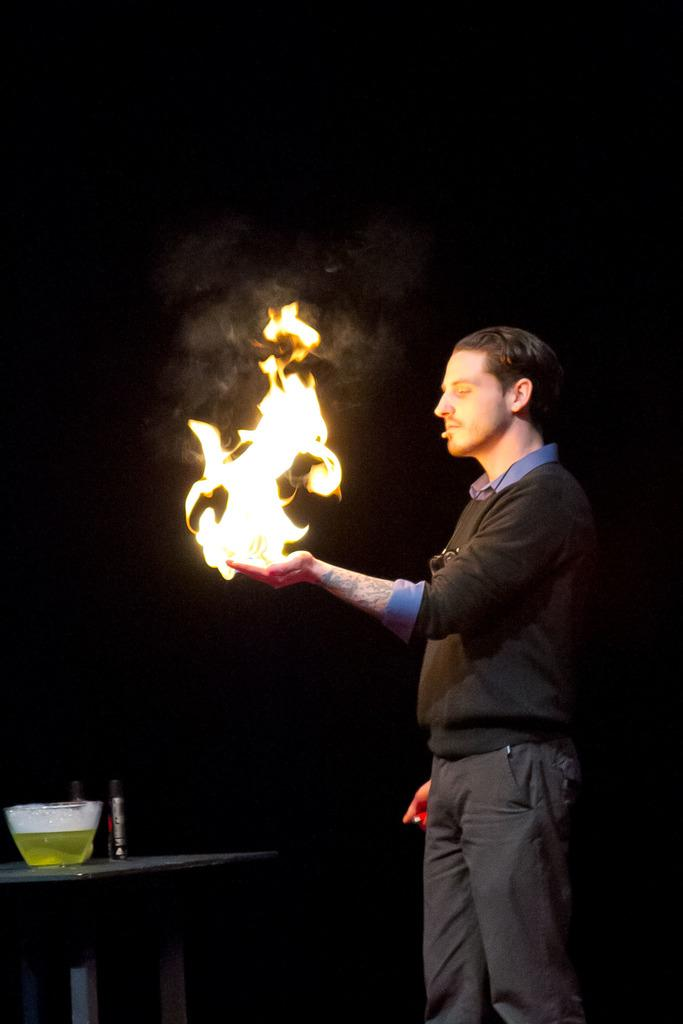What is located on the right side of the image? There is a man on the right side of the image. What is the man wearing? The man is wearing a t-shirt and trousers. What is the man holding in the image? The man is holding fire. What can be seen on the left side of the image? There is a table on the left side of the image. What items are on the table? There is a bowl and a bottle on the table. What type of potato is being used as a flag in the image? There is no potato or flag present in the image. What drug is the man holding in the image? The man is holding fire, not a drug, in the image. 